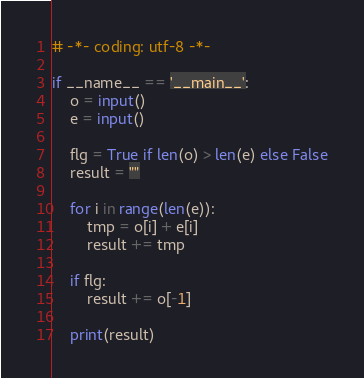<code> <loc_0><loc_0><loc_500><loc_500><_Python_># -*- coding: utf-8 -*-

if __name__ == '__main__':
    o = input()
    e = input()

    flg = True if len(o) > len(e) else False
    result = ""

    for i in range(len(e)):
        tmp = o[i] + e[i]
        result += tmp

    if flg:
        result += o[-1]

    print(result)
</code> 